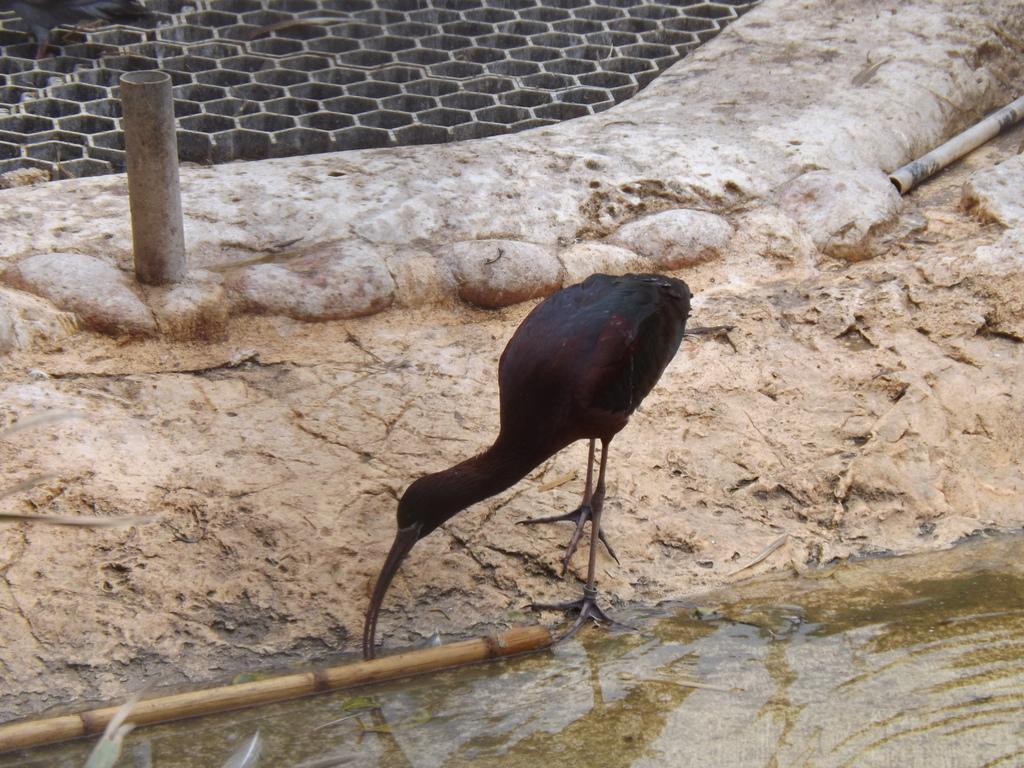Describe this image in one or two sentences. In this image we can see there is a bird, water and stick. There are objects. 